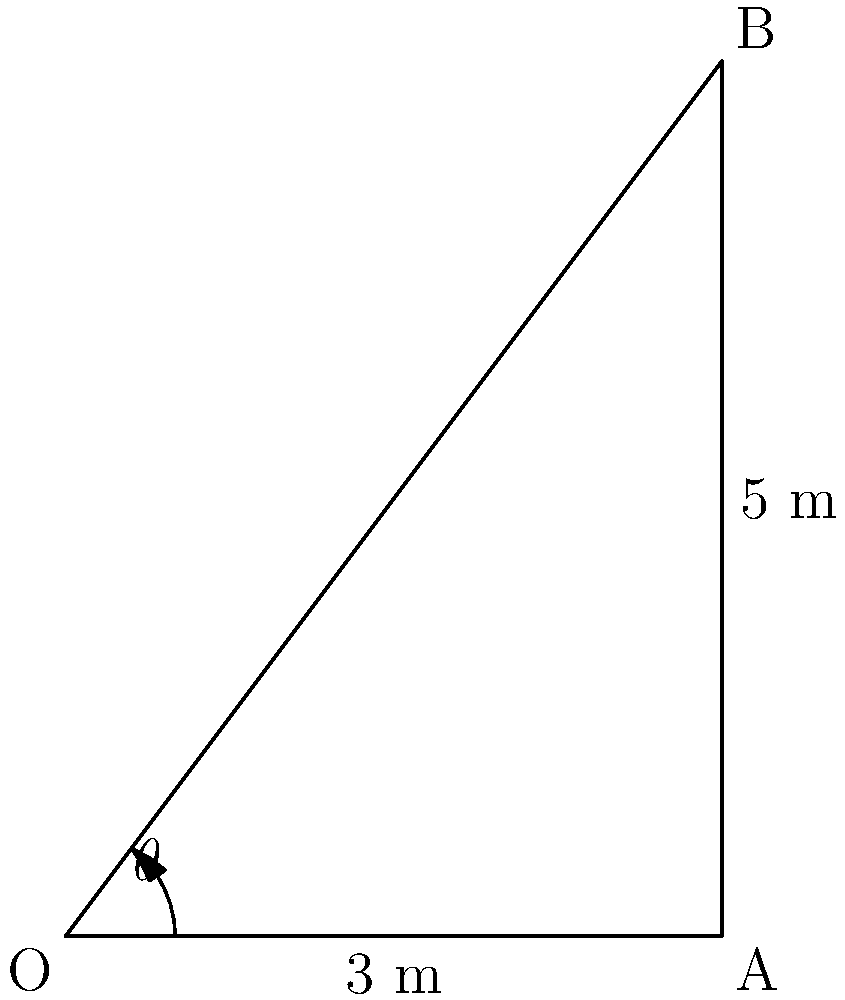As a dedicated TV enthusiast, you're setting up a satellite dish for optimal signal reception. The dish needs to be rotated to an angle $\theta$ from the horizontal. If the dish is mounted 3 meters from the base of a building and needs to point at a receiver 5 meters up the building's wall, what angle $\theta$ (in degrees) should the dish be rotated to get the best signal? Let's approach this step-by-step:

1) We can see that this forms a right-angled triangle, where:
   - The base (horizontal distance) is 3 meters
   - The height (vertical distance) is 4 meters (5 - 1 = 4)
   - The angle we're looking for is $\theta$

2) In a right-angled triangle, we can use the tangent function to find the angle:

   $\tan(\theta) = \frac{\text{opposite}}{\text{adjacent}} = \frac{\text{height}}{\text{base}}$

3) Substituting our values:

   $\tan(\theta) = \frac{4}{3}$

4) To find $\theta$, we need to use the inverse tangent (arctan or $\tan^{-1}$):

   $\theta = \tan^{-1}(\frac{4}{3})$

5) Using a calculator or trigonometric tables:

   $\theta \approx 53.13010235415598$ degrees

6) Rounding to two decimal places:

   $\theta \approx 53.13$ degrees

Therefore, the satellite dish should be rotated approximately 53.13 degrees from the horizontal to receive the best TV signal.
Answer: $53.13^{\circ}$ 